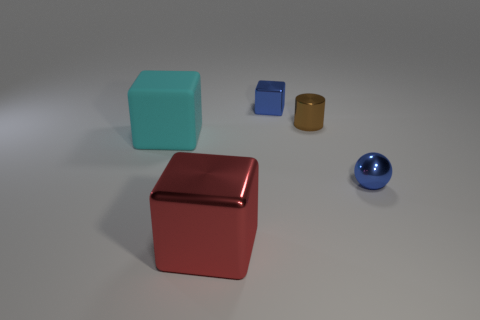What number of other things are the same material as the red object?
Make the answer very short. 3. Do the big object that is behind the big metal cube and the brown shiny object have the same shape?
Make the answer very short. No. What number of tiny things are brown spheres or metallic cylinders?
Your answer should be compact. 1. Is the number of small blocks on the left side of the matte object the same as the number of tiny brown shiny cylinders in front of the metal cylinder?
Your answer should be compact. Yes. How many other things are there of the same color as the matte block?
Provide a succinct answer. 0. There is a tiny metallic cylinder; is its color the same as the block behind the large rubber object?
Your answer should be compact. No. How many red objects are either cubes or big metal things?
Keep it short and to the point. 1. Are there the same number of matte objects that are in front of the cyan object and tiny green matte blocks?
Provide a short and direct response. Yes. Is there anything else that has the same size as the red metallic object?
Your response must be concise. Yes. There is another big rubber thing that is the same shape as the red object; what is its color?
Keep it short and to the point. Cyan. 